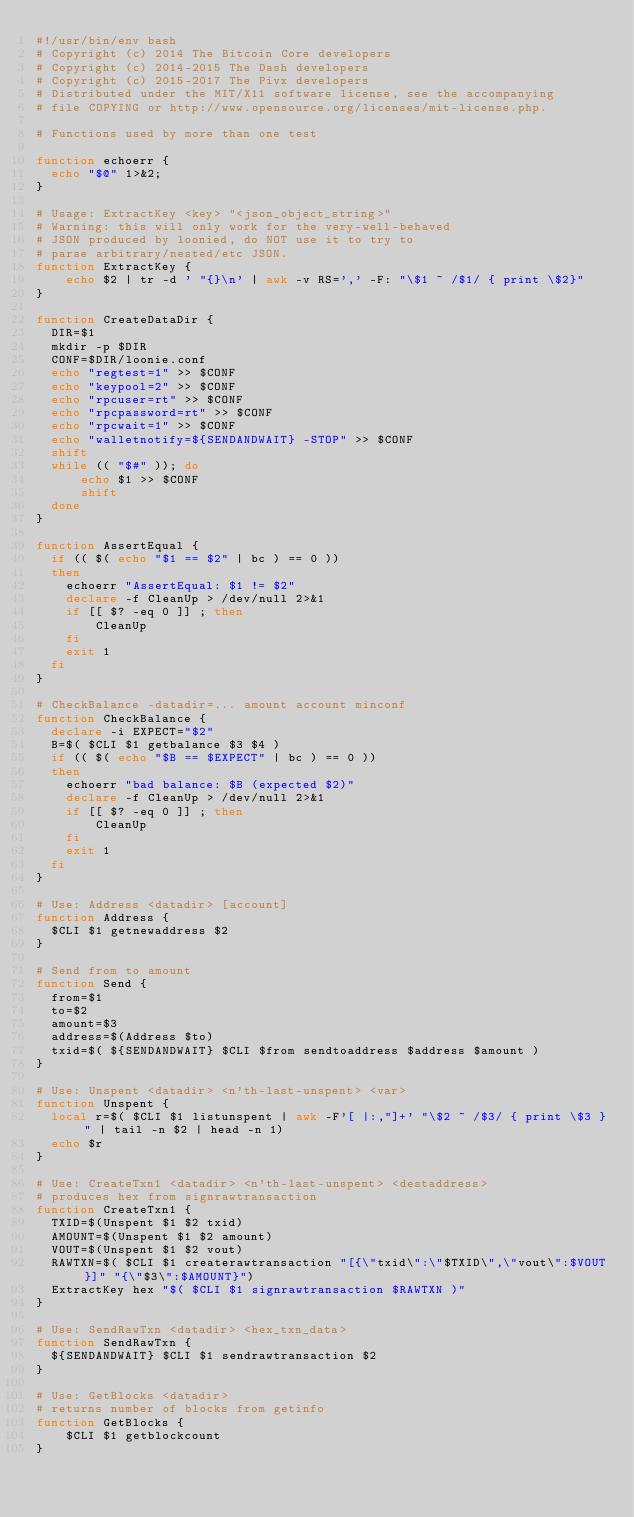Convert code to text. <code><loc_0><loc_0><loc_500><loc_500><_Bash_>#!/usr/bin/env bash
# Copyright (c) 2014 The Bitcoin Core developers
# Copyright (c) 2014-2015 The Dash developers
# Copyright (c) 2015-2017 The Pivx developers
# Distributed under the MIT/X11 software license, see the accompanying
# file COPYING or http://www.opensource.org/licenses/mit-license.php.

# Functions used by more than one test

function echoerr {
  echo "$@" 1>&2;
}

# Usage: ExtractKey <key> "<json_object_string>"
# Warning: this will only work for the very-well-behaved
# JSON produced by loonied, do NOT use it to try to
# parse arbitrary/nested/etc JSON.
function ExtractKey {
    echo $2 | tr -d ' "{}\n' | awk -v RS=',' -F: "\$1 ~ /$1/ { print \$2}"
}

function CreateDataDir {
  DIR=$1
  mkdir -p $DIR
  CONF=$DIR/loonie.conf
  echo "regtest=1" >> $CONF
  echo "keypool=2" >> $CONF
  echo "rpcuser=rt" >> $CONF
  echo "rpcpassword=rt" >> $CONF
  echo "rpcwait=1" >> $CONF
  echo "walletnotify=${SENDANDWAIT} -STOP" >> $CONF
  shift
  while (( "$#" )); do
      echo $1 >> $CONF
      shift
  done
}

function AssertEqual {
  if (( $( echo "$1 == $2" | bc ) == 0 ))
  then
    echoerr "AssertEqual: $1 != $2"
    declare -f CleanUp > /dev/null 2>&1
    if [[ $? -eq 0 ]] ; then
        CleanUp
    fi
    exit 1
  fi
}

# CheckBalance -datadir=... amount account minconf
function CheckBalance {
  declare -i EXPECT="$2"
  B=$( $CLI $1 getbalance $3 $4 )
  if (( $( echo "$B == $EXPECT" | bc ) == 0 ))
  then
    echoerr "bad balance: $B (expected $2)"
    declare -f CleanUp > /dev/null 2>&1
    if [[ $? -eq 0 ]] ; then
        CleanUp
    fi
    exit 1
  fi
}

# Use: Address <datadir> [account]
function Address {
  $CLI $1 getnewaddress $2
}

# Send from to amount
function Send {
  from=$1
  to=$2
  amount=$3
  address=$(Address $to)
  txid=$( ${SENDANDWAIT} $CLI $from sendtoaddress $address $amount )
}

# Use: Unspent <datadir> <n'th-last-unspent> <var>
function Unspent {
  local r=$( $CLI $1 listunspent | awk -F'[ |:,"]+' "\$2 ~ /$3/ { print \$3 }" | tail -n $2 | head -n 1)
  echo $r
}

# Use: CreateTxn1 <datadir> <n'th-last-unspent> <destaddress>
# produces hex from signrawtransaction
function CreateTxn1 {
  TXID=$(Unspent $1 $2 txid)
  AMOUNT=$(Unspent $1 $2 amount)
  VOUT=$(Unspent $1 $2 vout)
  RAWTXN=$( $CLI $1 createrawtransaction "[{\"txid\":\"$TXID\",\"vout\":$VOUT}]" "{\"$3\":$AMOUNT}")
  ExtractKey hex "$( $CLI $1 signrawtransaction $RAWTXN )"
}

# Use: SendRawTxn <datadir> <hex_txn_data>
function SendRawTxn {
  ${SENDANDWAIT} $CLI $1 sendrawtransaction $2
}

# Use: GetBlocks <datadir>
# returns number of blocks from getinfo
function GetBlocks {
    $CLI $1 getblockcount
}
</code> 